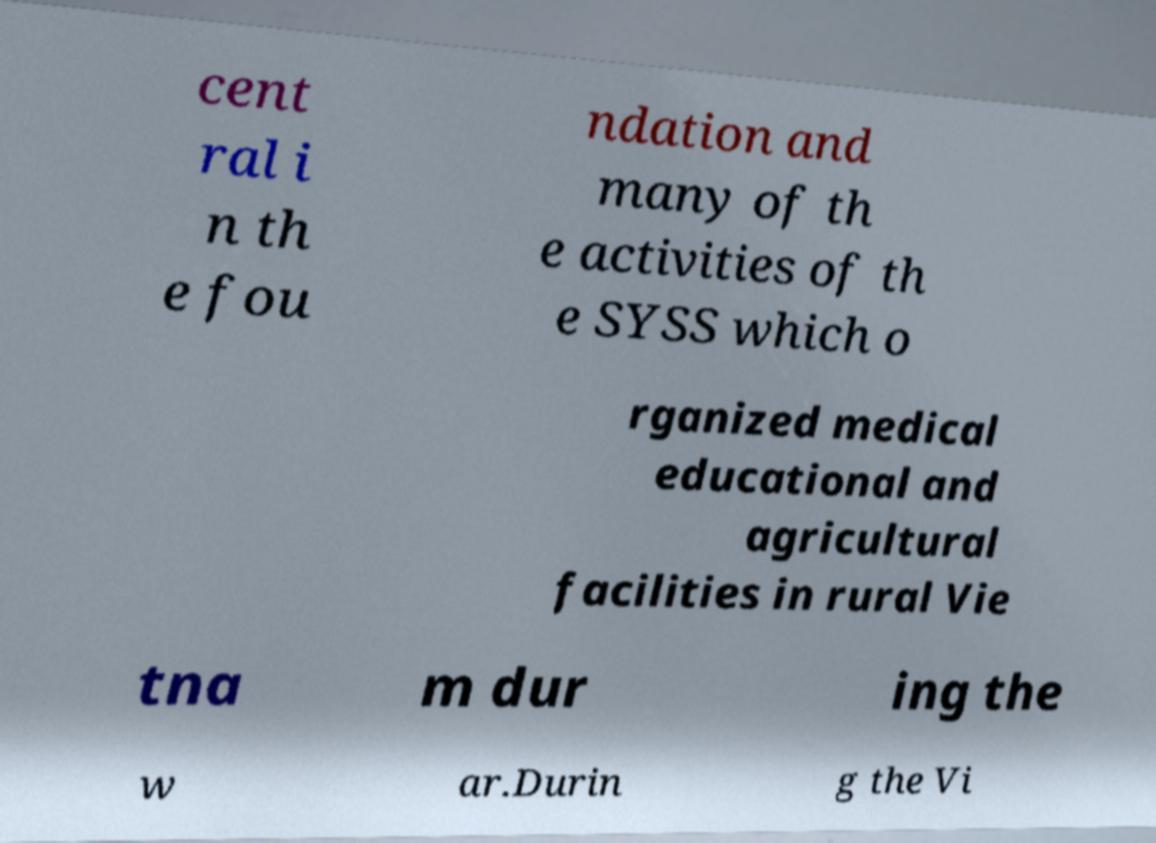Could you assist in decoding the text presented in this image and type it out clearly? cent ral i n th e fou ndation and many of th e activities of th e SYSS which o rganized medical educational and agricultural facilities in rural Vie tna m dur ing the w ar.Durin g the Vi 